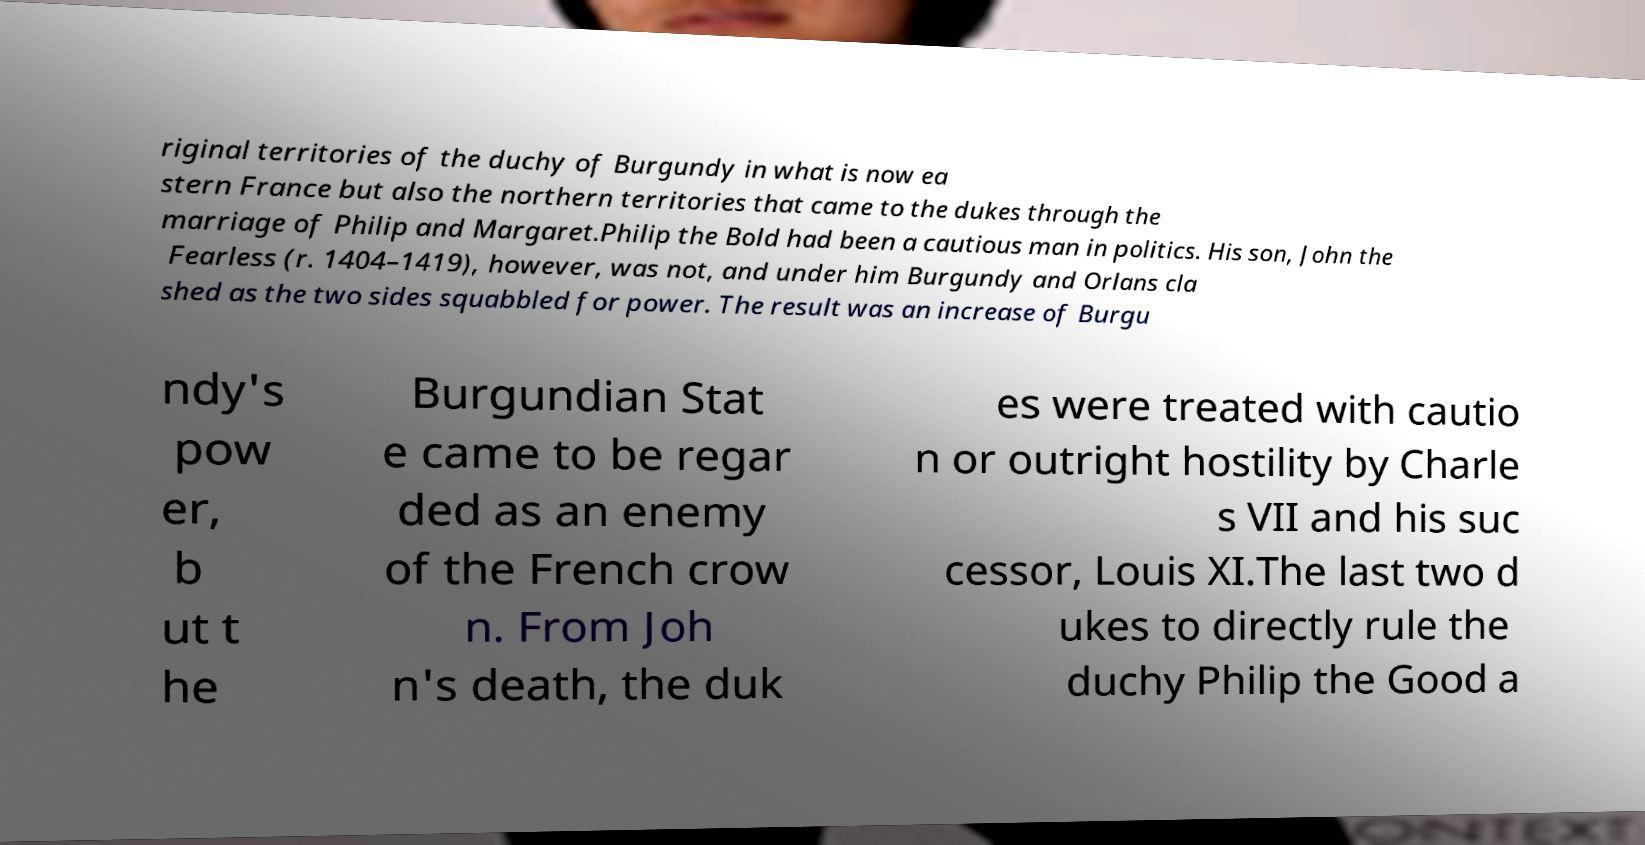Please identify and transcribe the text found in this image. riginal territories of the duchy of Burgundy in what is now ea stern France but also the northern territories that came to the dukes through the marriage of Philip and Margaret.Philip the Bold had been a cautious man in politics. His son, John the Fearless (r. 1404–1419), however, was not, and under him Burgundy and Orlans cla shed as the two sides squabbled for power. The result was an increase of Burgu ndy's pow er, b ut t he Burgundian Stat e came to be regar ded as an enemy of the French crow n. From Joh n's death, the duk es were treated with cautio n or outright hostility by Charle s VII and his suc cessor, Louis XI.The last two d ukes to directly rule the duchy Philip the Good a 